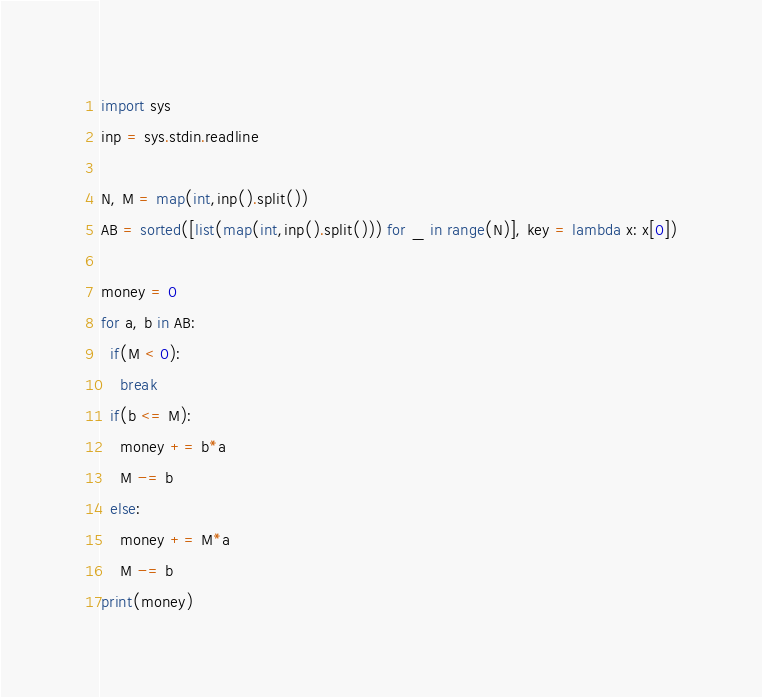Convert code to text. <code><loc_0><loc_0><loc_500><loc_500><_Python_>import sys
inp = sys.stdin.readline

N, M = map(int,inp().split())
AB = sorted([list(map(int,inp().split())) for _ in range(N)], key = lambda x: x[0])

money = 0
for a, b in AB:
  if(M < 0):
    break
  if(b <= M):
    money += b*a
    M -= b
  else:
    money += M*a
    M -= b
print(money)</code> 